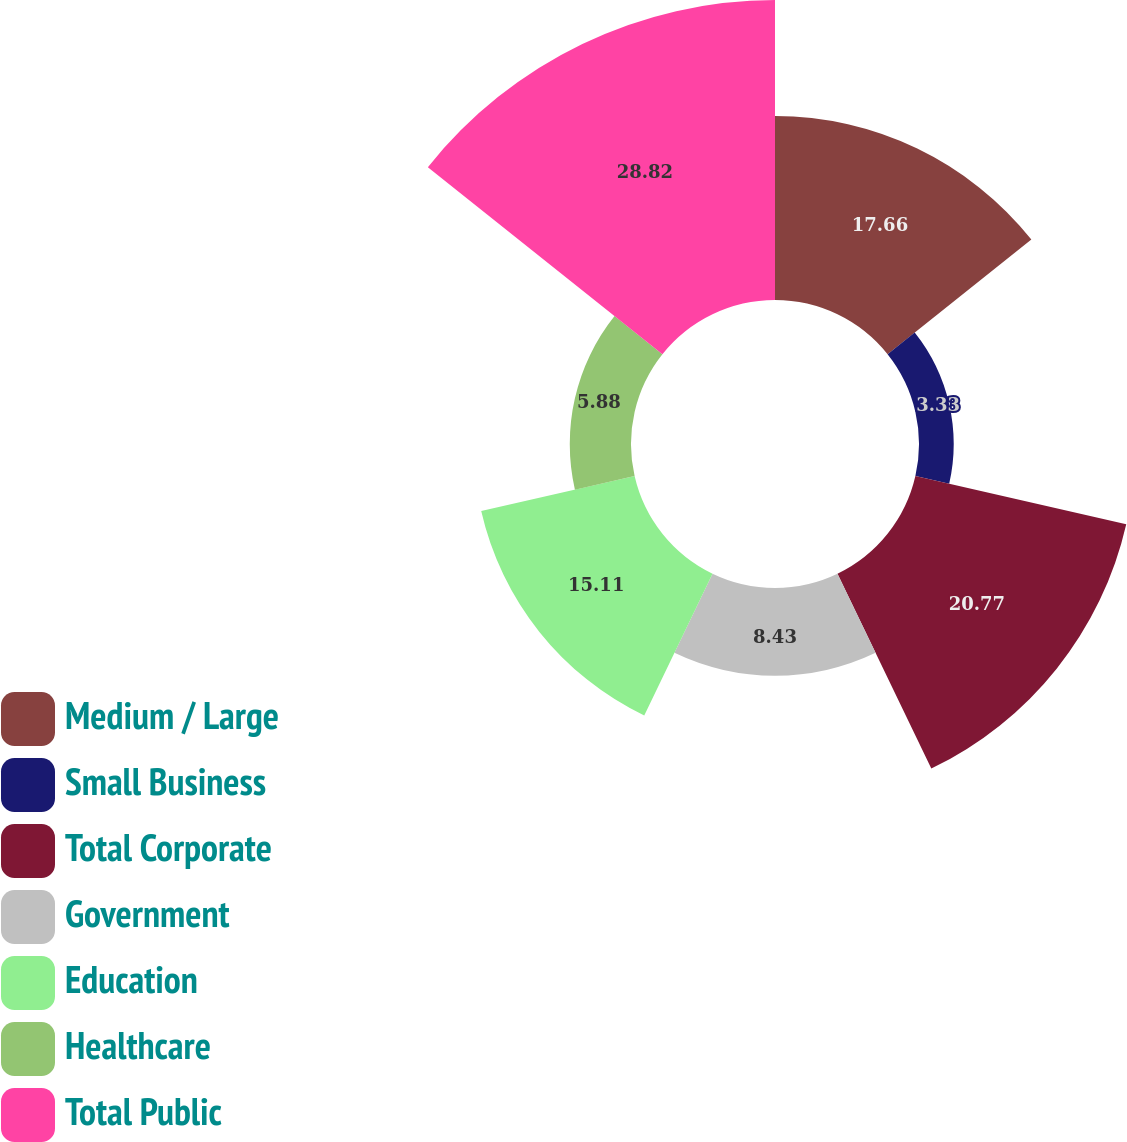Convert chart. <chart><loc_0><loc_0><loc_500><loc_500><pie_chart><fcel>Medium / Large<fcel>Small Business<fcel>Total Corporate<fcel>Government<fcel>Education<fcel>Healthcare<fcel>Total Public<nl><fcel>17.66%<fcel>3.33%<fcel>20.77%<fcel>8.43%<fcel>15.11%<fcel>5.88%<fcel>28.81%<nl></chart> 